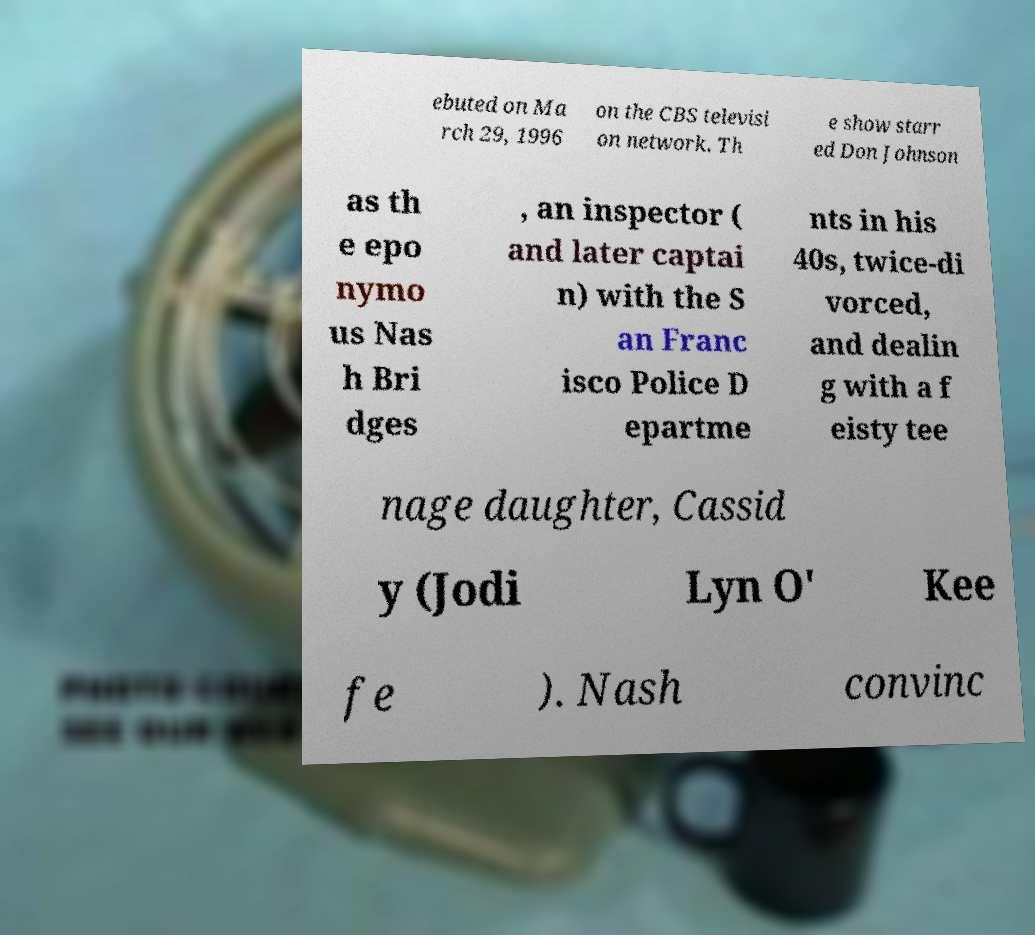Could you extract and type out the text from this image? ebuted on Ma rch 29, 1996 on the CBS televisi on network. Th e show starr ed Don Johnson as th e epo nymo us Nas h Bri dges , an inspector ( and later captai n) with the S an Franc isco Police D epartme nts in his 40s, twice-di vorced, and dealin g with a f eisty tee nage daughter, Cassid y (Jodi Lyn O' Kee fe ). Nash convinc 